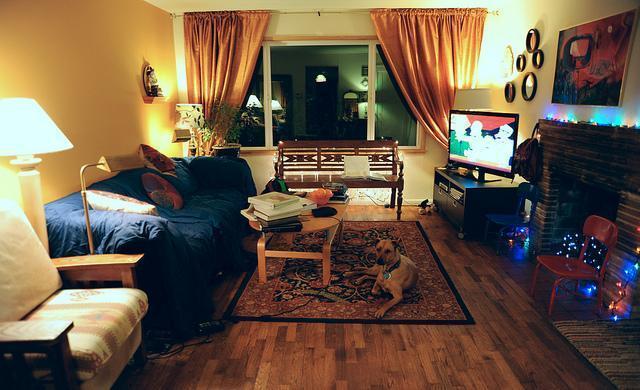How many benches are there?
Give a very brief answer. 1. How many chairs are there?
Give a very brief answer. 2. 